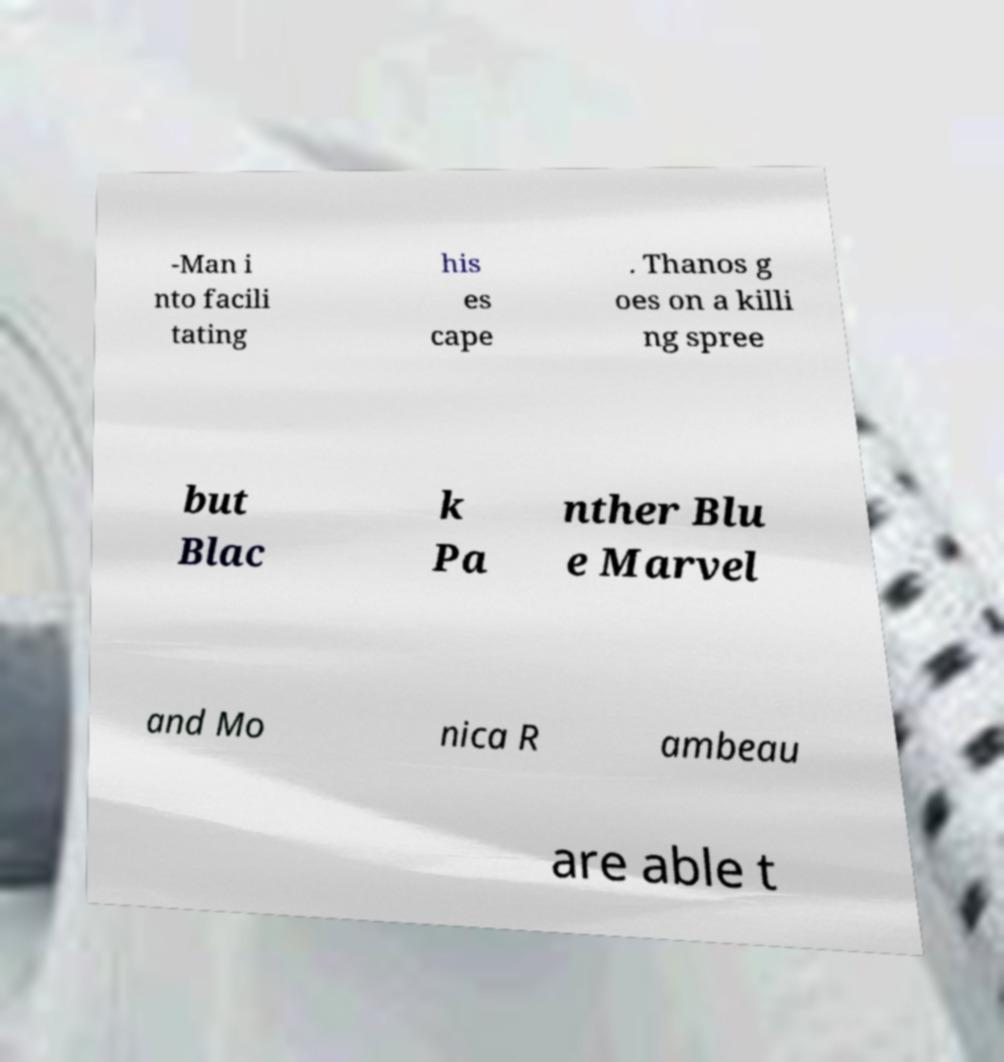I need the written content from this picture converted into text. Can you do that? -Man i nto facili tating his es cape . Thanos g oes on a killi ng spree but Blac k Pa nther Blu e Marvel and Mo nica R ambeau are able t 